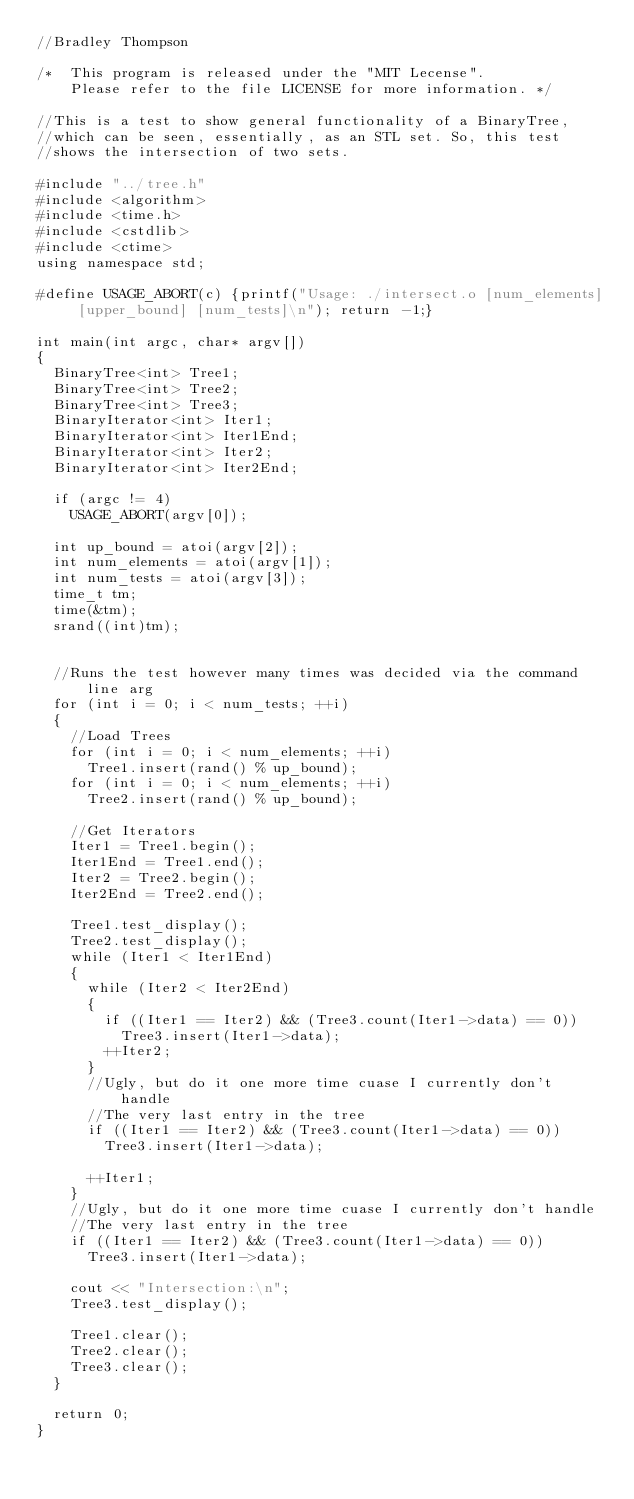<code> <loc_0><loc_0><loc_500><loc_500><_C++_>//Bradley Thompson

/*  This program is released under the "MIT Lecense".
    Please refer to the file LICENSE for more information. */ 

//This is a test to show general functionality of a BinaryTree,
//which can be seen, essentially, as an STL set. So, this test
//shows the intersection of two sets.

#include "../tree.h"
#include <algorithm>
#include <time.h>
#include <cstdlib>
#include <ctime>
using namespace std;

#define USAGE_ABORT(c) {printf("Usage: ./intersect.o [num_elements] [upper_bound] [num_tests]\n"); return -1;}

int main(int argc, char* argv[])
{
  BinaryTree<int> Tree1;
  BinaryTree<int> Tree2;
  BinaryTree<int> Tree3;
  BinaryIterator<int> Iter1;
  BinaryIterator<int> Iter1End;
  BinaryIterator<int> Iter2;
  BinaryIterator<int> Iter2End;
 
  if (argc != 4)
    USAGE_ABORT(argv[0]); 

  int up_bound = atoi(argv[2]);
  int num_elements = atoi(argv[1]);
  int num_tests = atoi(argv[3]);
  time_t tm;  
  time(&tm); 
  srand((int)tm); 


  //Runs the test however many times was decided via the command line arg
  for (int i = 0; i < num_tests; ++i)
  {
    //Load Trees 
    for (int i = 0; i < num_elements; ++i)
      Tree1.insert(rand() % up_bound);
    for (int i = 0; i < num_elements; ++i)
      Tree2.insert(rand() % up_bound);

    //Get Iterators
    Iter1 = Tree1.begin();
    Iter1End = Tree1.end();
    Iter2 = Tree2.begin();
    Iter2End = Tree2.end();
   
    Tree1.test_display();
    Tree2.test_display(); 
    while (Iter1 < Iter1End)
    {
      while (Iter2 < Iter2End)
      {
        if ((Iter1 == Iter2) && (Tree3.count(Iter1->data) == 0))
          Tree3.insert(Iter1->data);
        ++Iter2;
      }
      //Ugly, but do it one more time cuase I currently don't handle
      //The very last entry in the tree
      if ((Iter1 == Iter2) && (Tree3.count(Iter1->data) == 0))
        Tree3.insert(Iter1->data);
        
      ++Iter1; 
    }
    //Ugly, but do it one more time cuase I currently don't handle
    //The very last entry in the tree
    if ((Iter1 == Iter2) && (Tree3.count(Iter1->data) == 0))
      Tree3.insert(Iter1->data);
    
    cout << "Intersection:\n"; 
    Tree3.test_display();

    Tree1.clear();
    Tree2.clear();
    Tree3.clear();
  }

  return 0;
}
</code> 